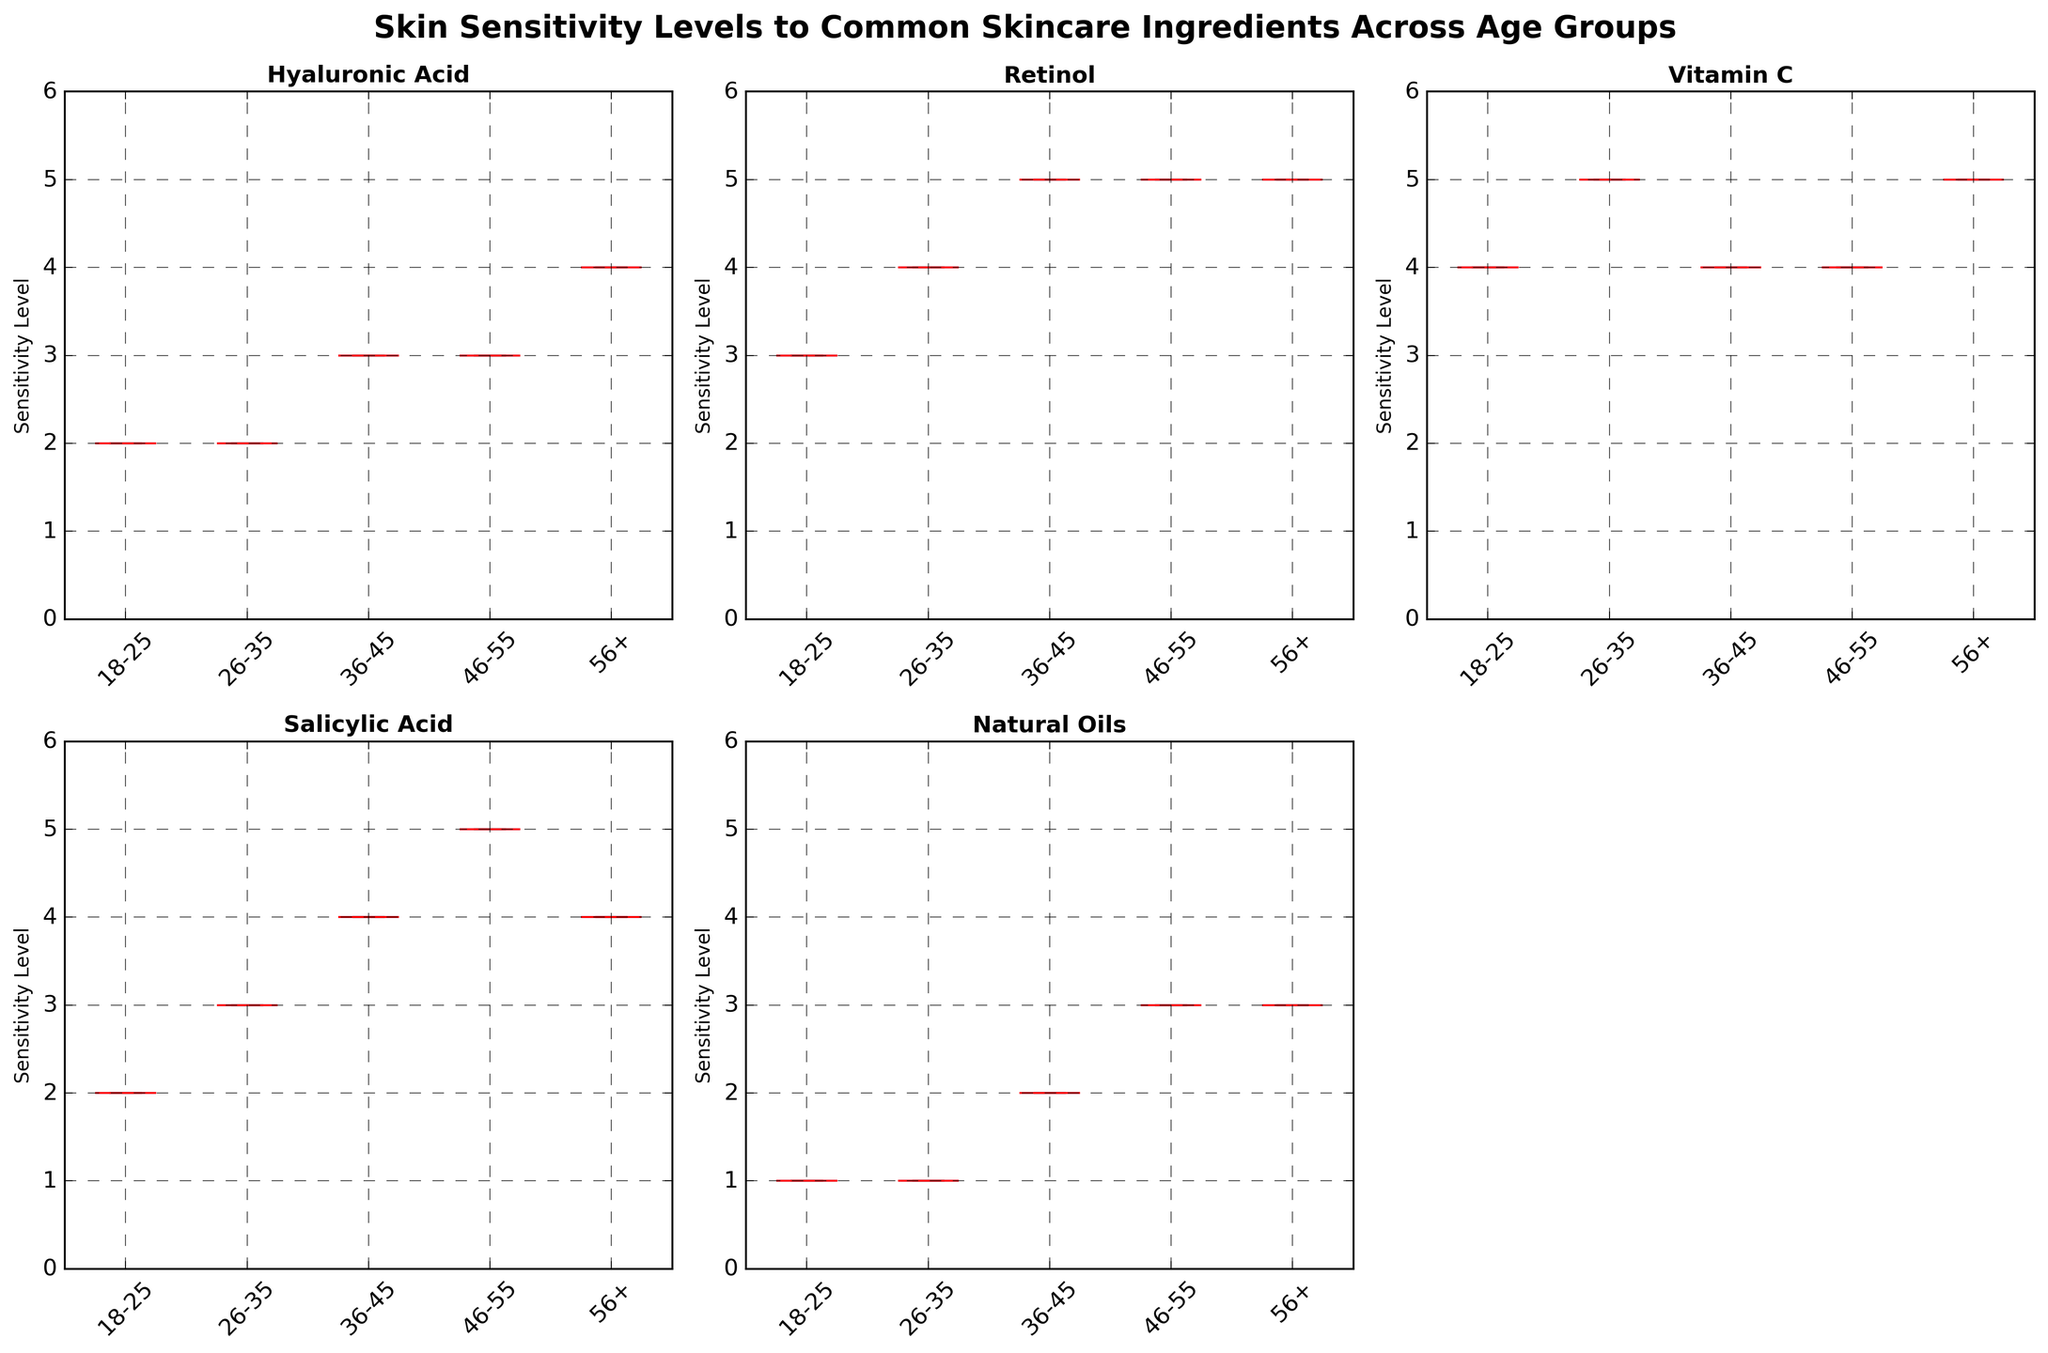What's the title of the plot? The title of the plot is located at the top center of the figure. It is written in bold and slightly larger font size.
Answer: Skin Sensitivity Levels to Common Skincare Ingredients Across Age Groups How many age groups are depicted in the figure? The x-axis labels of each box plot correspond to different age groups. Count the unique labels across all subplots.
Answer: 5 Which ingredient has the highest median sensitivity level for the 56+ age group? Identify the median lines on the box plots for the 56+ age group across all ingredients. The ingredient with the highest median line represents the highest median sensitivity level.
Answer: Vitamin C Which ingredient shows the least variability in sensitivity levels for the 18-25 age group? Look at the range between the whiskers (the maximum and minimum marks) for the 18-25 age group box plots. The smallest range indicates the least variability.
Answer: Natural Oils What’s the approximate range of sensitivity levels for Salicylic Acid in the 36-45 age group? The range is determined by the distance between the minimum and maximum whiskers of the box plot for Salicylic Acid in the 36-45 age group.
Answer: 2-4 Compare the median sensitivity levels of Retinol between the 26-35 and 36-45 age groups. Which one is higher? Assess the positions of the median lines on the box plots for Retinol in the 26-35 and 36-45 age groups. Identify the higher median.
Answer: 36-45 age group What age group shows the maximum sensitivity to Hyaluronic Acid? Determine the box plot with the highest median value line for Hyaluronic Acid across all age groups.
Answer: 56+ age group Which age group shows the greatest sensitivity to natural oils? Compare the median lines of the box plots for Natural Oils across all age groups. The highest median line indicates the greatest sensitivity.
Answer: 46-55 age group How does sensitivity to Vitamin C change with age? Look at the median lines of the box plots for Vitamin C across different age groups and describe the trend.
Answer: Increases 